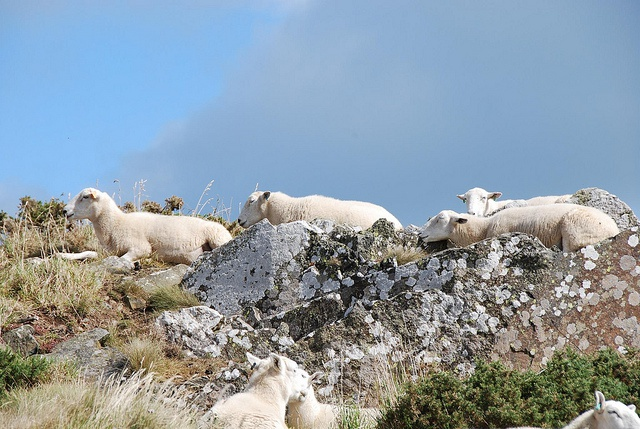Describe the objects in this image and their specific colors. I can see sheep in darkgray, lightgray, and tan tones, sheep in darkgray, lightgray, and gray tones, sheep in darkgray, ivory, lightgray, and gray tones, sheep in darkgray, white, gray, and lightgray tones, and sheep in darkgray, lightgray, and tan tones in this image. 